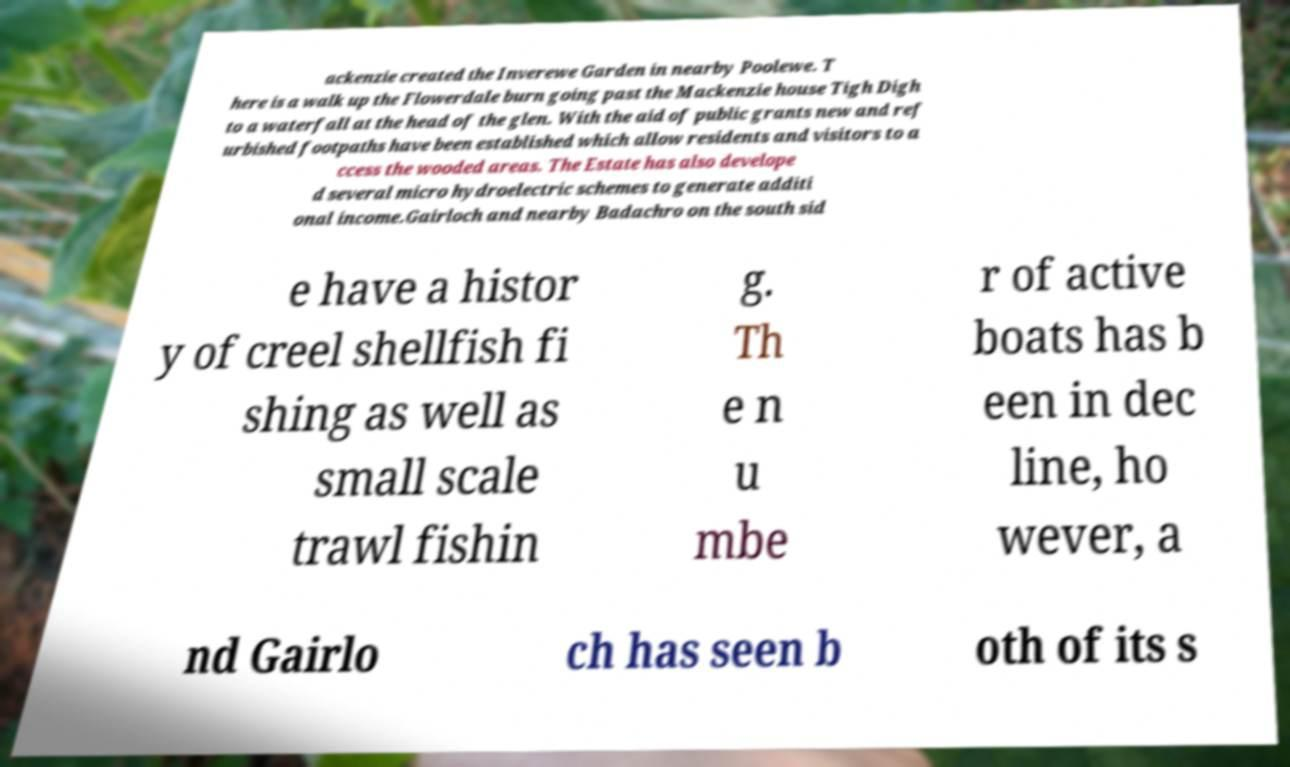There's text embedded in this image that I need extracted. Can you transcribe it verbatim? ackenzie created the Inverewe Garden in nearby Poolewe. T here is a walk up the Flowerdale burn going past the Mackenzie house Tigh Digh to a waterfall at the head of the glen. With the aid of public grants new and ref urbished footpaths have been established which allow residents and visitors to a ccess the wooded areas. The Estate has also develope d several micro hydroelectric schemes to generate additi onal income.Gairloch and nearby Badachro on the south sid e have a histor y of creel shellfish fi shing as well as small scale trawl fishin g. Th e n u mbe r of active boats has b een in dec line, ho wever, a nd Gairlo ch has seen b oth of its s 